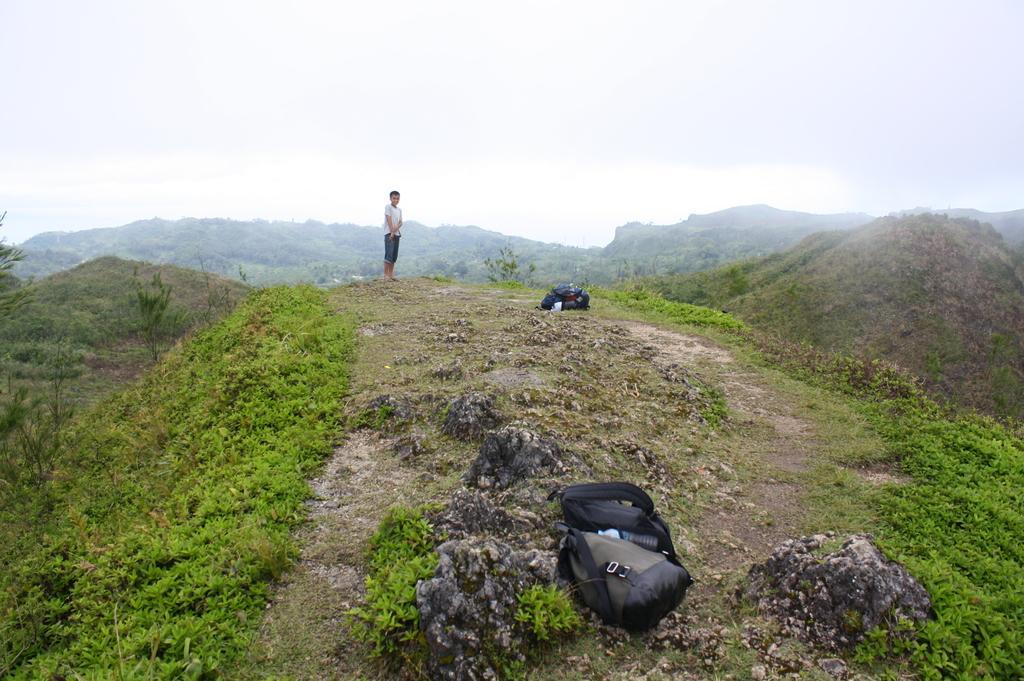How would you summarize this image in a sentence or two? In this image we can see a person standing on the ground. Here we can see bags, plants, grass, and mountains. In the background there is sky. 